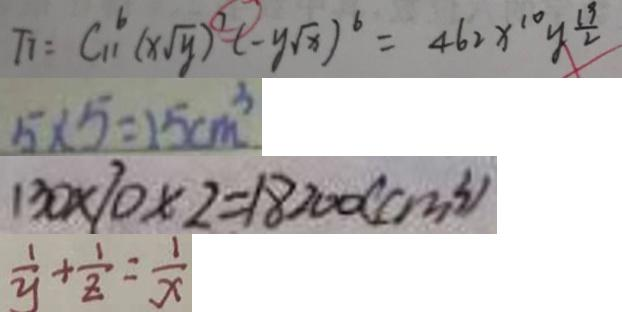<formula> <loc_0><loc_0><loc_500><loc_500>T _ { 7 } = C _ { 1 1 } ^ { 6 } ( x \sqrt { y } ) ^ { 7 } ( - y \sqrt { x } ) ^ { 6 } = 4 6 2 x ^ { 1 0 } y ^ { \frac { 1 9 } { 2 } } 
 5 \times 5 = 2 5 c m ^ { 3 } 
 1 3 0 \times 1 0 \times 2 = 1 8 2 0 0 ( c m ^ { 3 } ) 
 \frac { 1 } { y } + \frac { 1 } { z } = \frac { 1 } { x }</formula> 